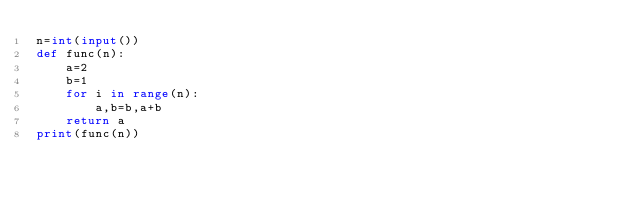<code> <loc_0><loc_0><loc_500><loc_500><_Python_>n=int(input())
def func(n):
    a=2
    b=1
    for i in range(n):
        a,b=b,a+b
    return a
print(func(n))</code> 